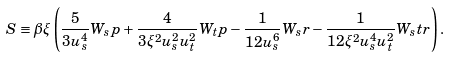Convert formula to latex. <formula><loc_0><loc_0><loc_500><loc_500>S \equiv \beta \xi \left ( \frac { 5 } { 3 u _ { s } ^ { 4 } } W _ { s } p + \frac { 4 } { 3 \xi ^ { 2 } u _ { s } ^ { 2 } u _ { t } ^ { 2 } } W _ { t } p - \frac { 1 } { 1 2 u _ { s } ^ { 6 } } W _ { s } r - \frac { 1 } { 1 2 \xi ^ { 2 } u _ { s } ^ { 4 } u _ { t } ^ { 2 } } W _ { s } t r \right ) .</formula> 